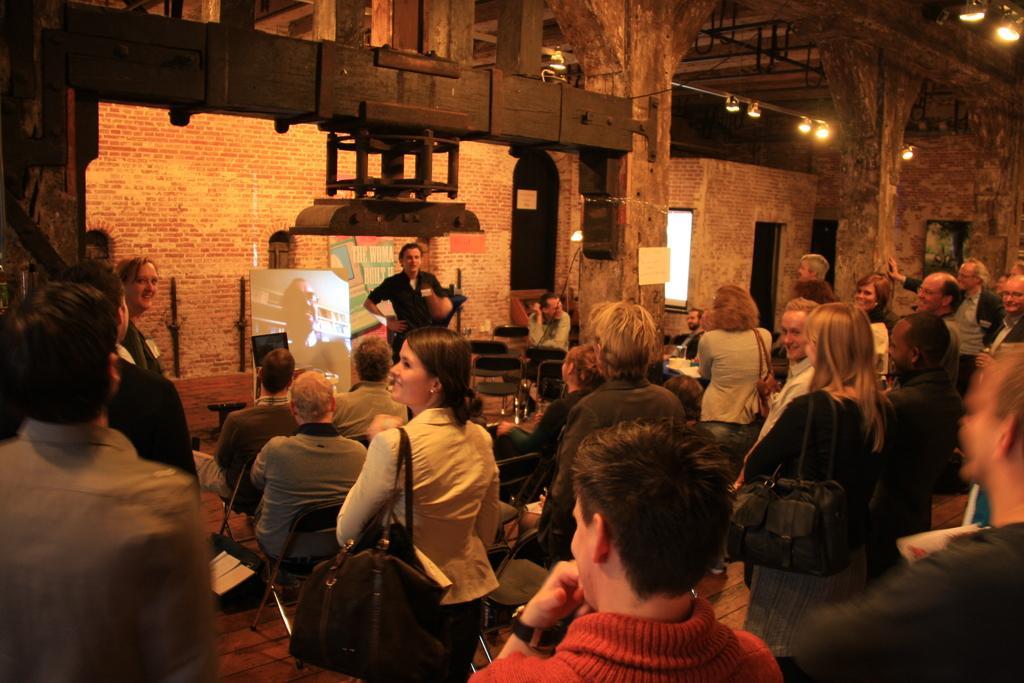How would you summarize this image in a sentence or two? This image consists of a woman wearing a backpack and at the right side of the woman there are some group of people standing and at the back ground there are some chairs , a man standing and talking , a small screen , and 2 speakers , hoarding and some lights attached to the poles. 